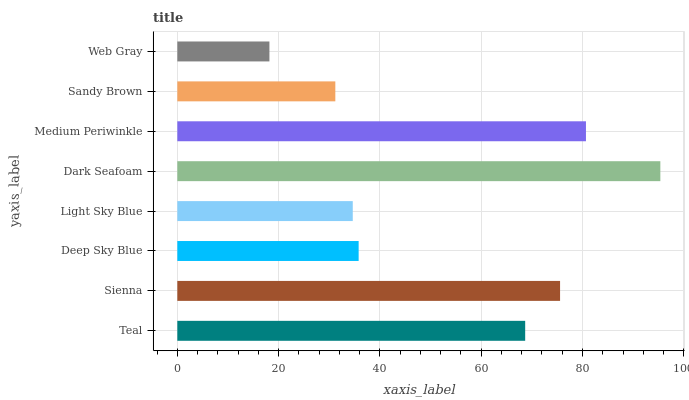Is Web Gray the minimum?
Answer yes or no. Yes. Is Dark Seafoam the maximum?
Answer yes or no. Yes. Is Sienna the minimum?
Answer yes or no. No. Is Sienna the maximum?
Answer yes or no. No. Is Sienna greater than Teal?
Answer yes or no. Yes. Is Teal less than Sienna?
Answer yes or no. Yes. Is Teal greater than Sienna?
Answer yes or no. No. Is Sienna less than Teal?
Answer yes or no. No. Is Teal the high median?
Answer yes or no. Yes. Is Deep Sky Blue the low median?
Answer yes or no. Yes. Is Deep Sky Blue the high median?
Answer yes or no. No. Is Teal the low median?
Answer yes or no. No. 